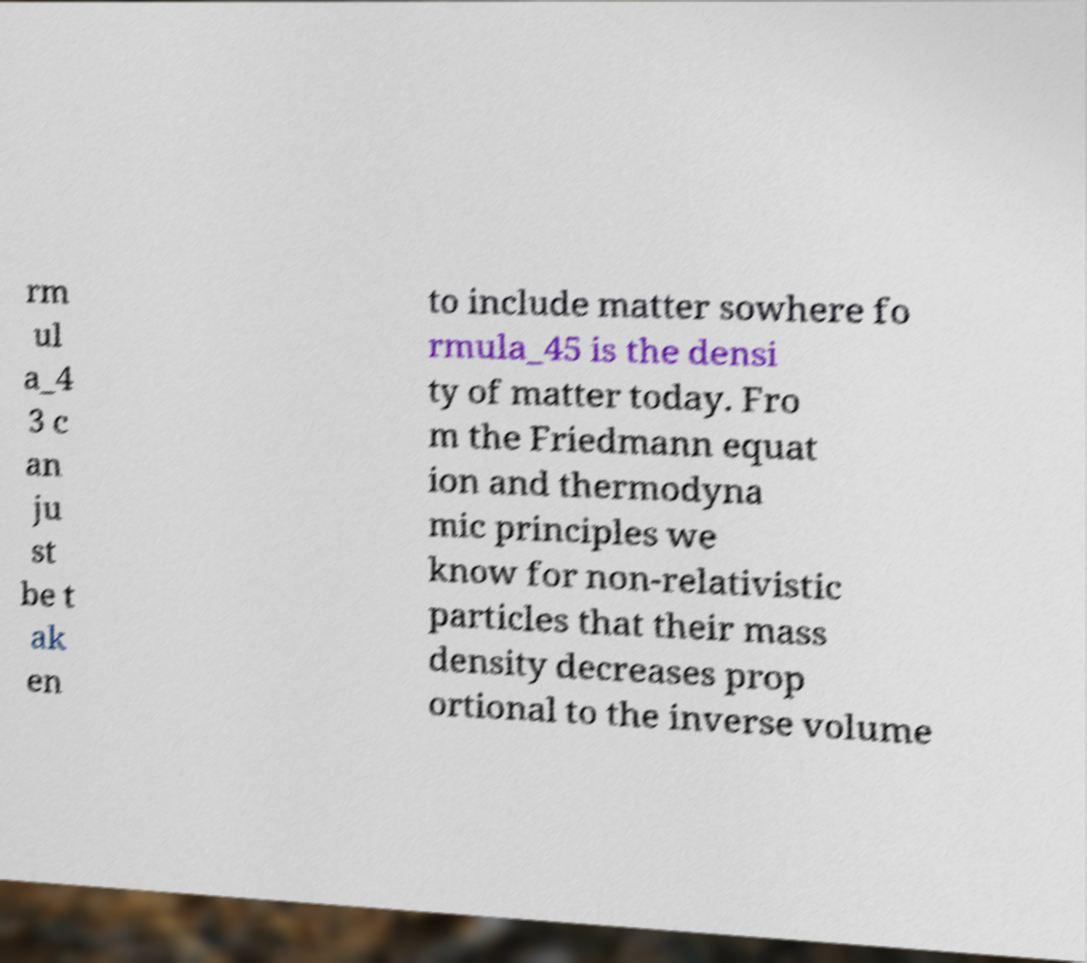Can you accurately transcribe the text from the provided image for me? rm ul a_4 3 c an ju st be t ak en to include matter sowhere fo rmula_45 is the densi ty of matter today. Fro m the Friedmann equat ion and thermodyna mic principles we know for non-relativistic particles that their mass density decreases prop ortional to the inverse volume 